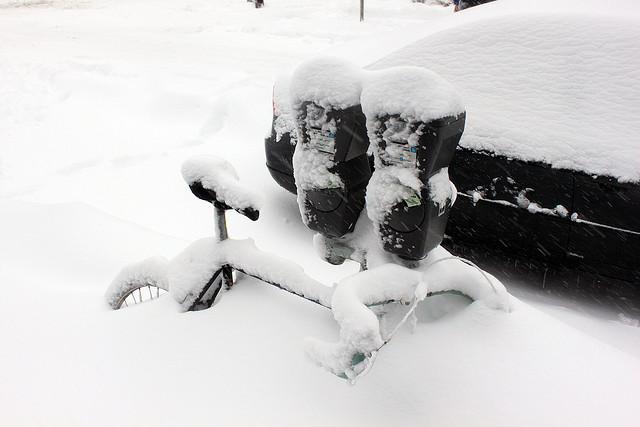Is the bike covered with snow?
Quick response, please. Yes. How many meters are there?
Concise answer only. 2. Is someone riding the bike?
Be succinct. No. 